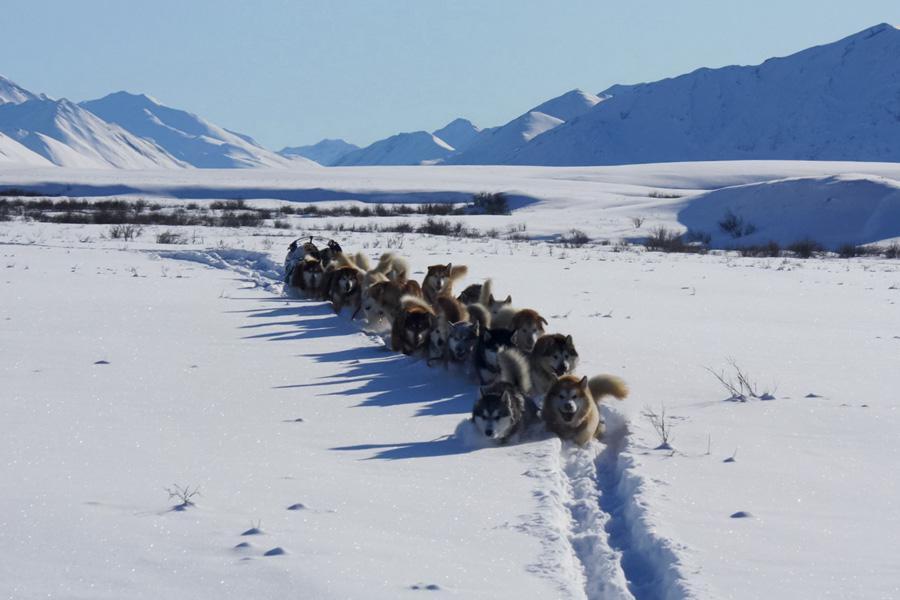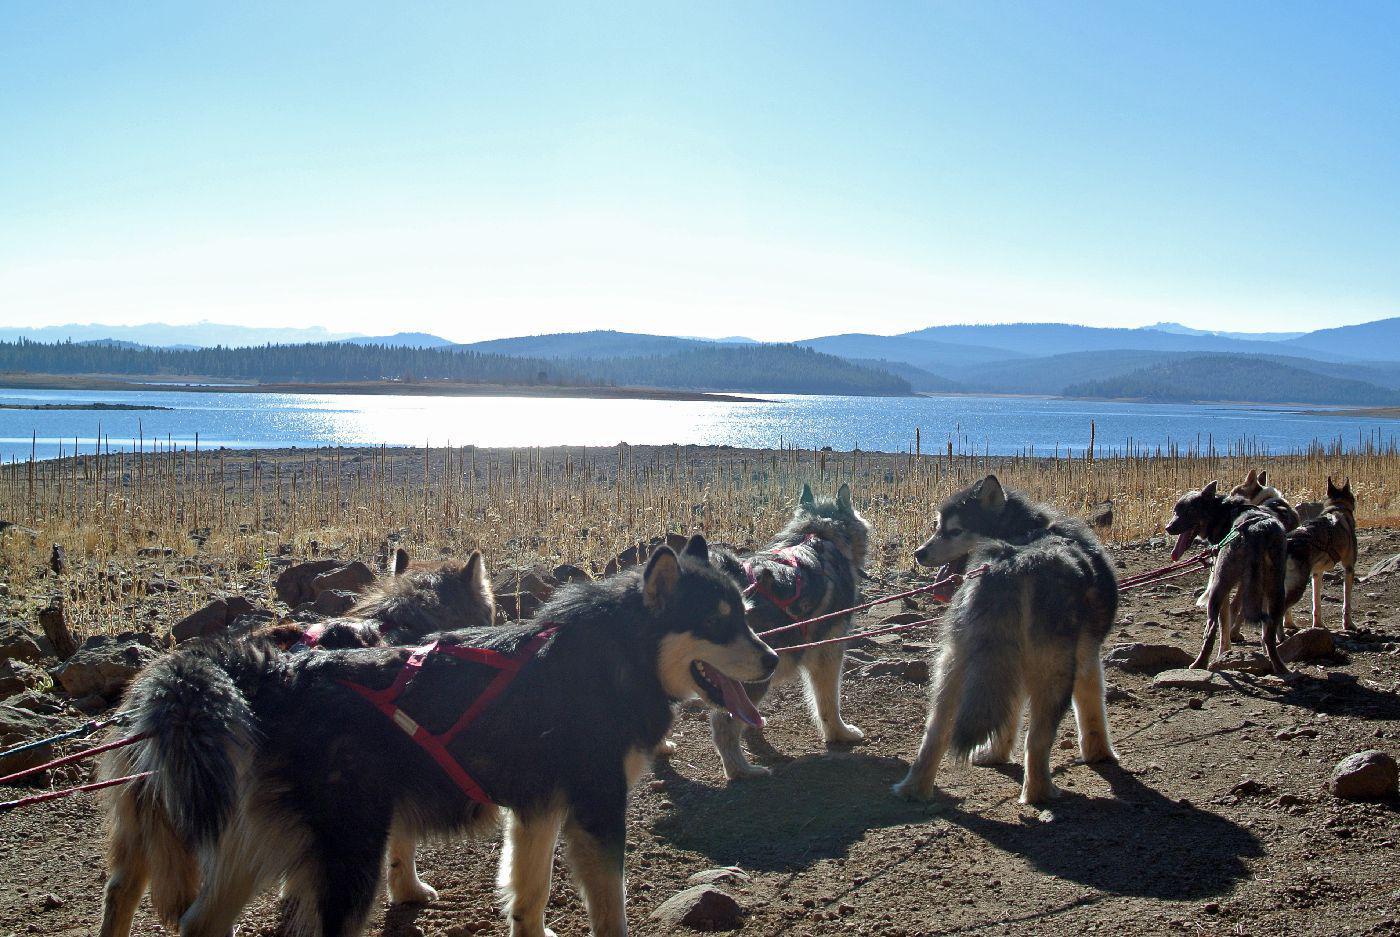The first image is the image on the left, the second image is the image on the right. Analyze the images presented: Is the assertion "There is a single dog in the snow in one image." valid? Answer yes or no. No. The first image is the image on the left, the second image is the image on the right. For the images displayed, is the sentence "Each image shows a line of at least four dogs heading in one direction, and at least one image shows dogs on a surface that is not covered in snow." factually correct? Answer yes or no. Yes. 